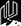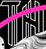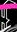Read the text content from these images in order, separated by a semicolon. #; TH; # 